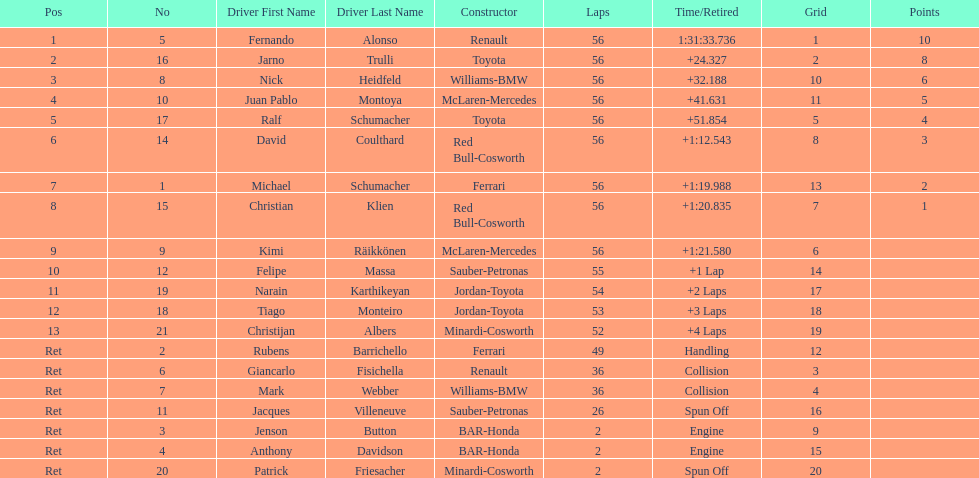How many drivers ended the race early because of engine problems? 2. 